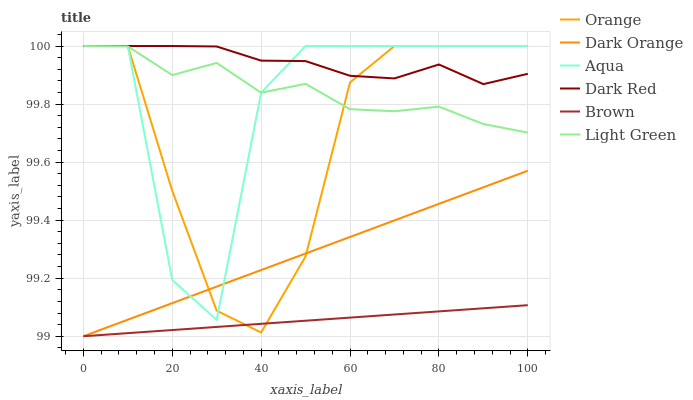Does Brown have the minimum area under the curve?
Answer yes or no. Yes. Does Dark Red have the maximum area under the curve?
Answer yes or no. Yes. Does Dark Red have the minimum area under the curve?
Answer yes or no. No. Does Brown have the maximum area under the curve?
Answer yes or no. No. Is Brown the smoothest?
Answer yes or no. Yes. Is Aqua the roughest?
Answer yes or no. Yes. Is Dark Red the smoothest?
Answer yes or no. No. Is Dark Red the roughest?
Answer yes or no. No. Does Dark Orange have the lowest value?
Answer yes or no. Yes. Does Dark Red have the lowest value?
Answer yes or no. No. Does Orange have the highest value?
Answer yes or no. Yes. Does Brown have the highest value?
Answer yes or no. No. Is Dark Orange less than Light Green?
Answer yes or no. Yes. Is Light Green greater than Dark Orange?
Answer yes or no. Yes. Does Dark Orange intersect Orange?
Answer yes or no. Yes. Is Dark Orange less than Orange?
Answer yes or no. No. Is Dark Orange greater than Orange?
Answer yes or no. No. Does Dark Orange intersect Light Green?
Answer yes or no. No. 